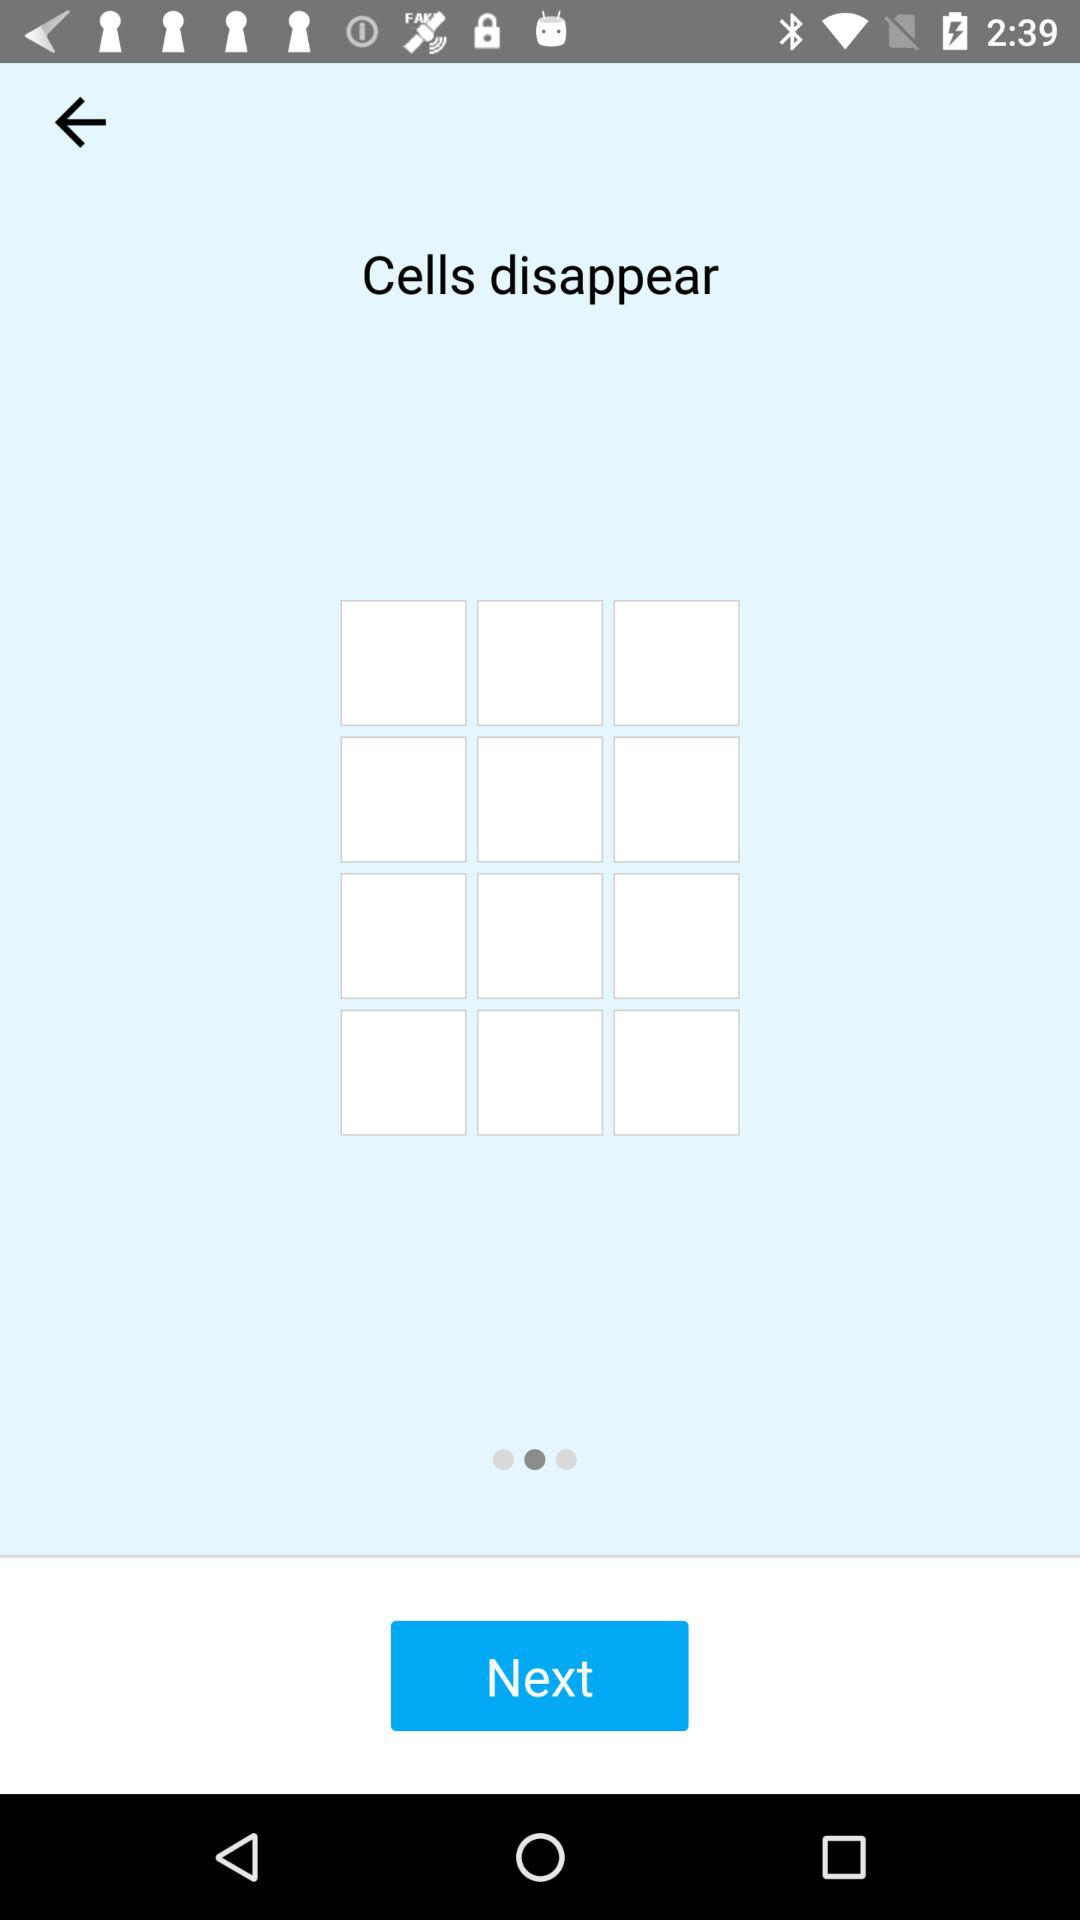How many cells can disappear?
When the provided information is insufficient, respond with <no answer>. <no answer> 